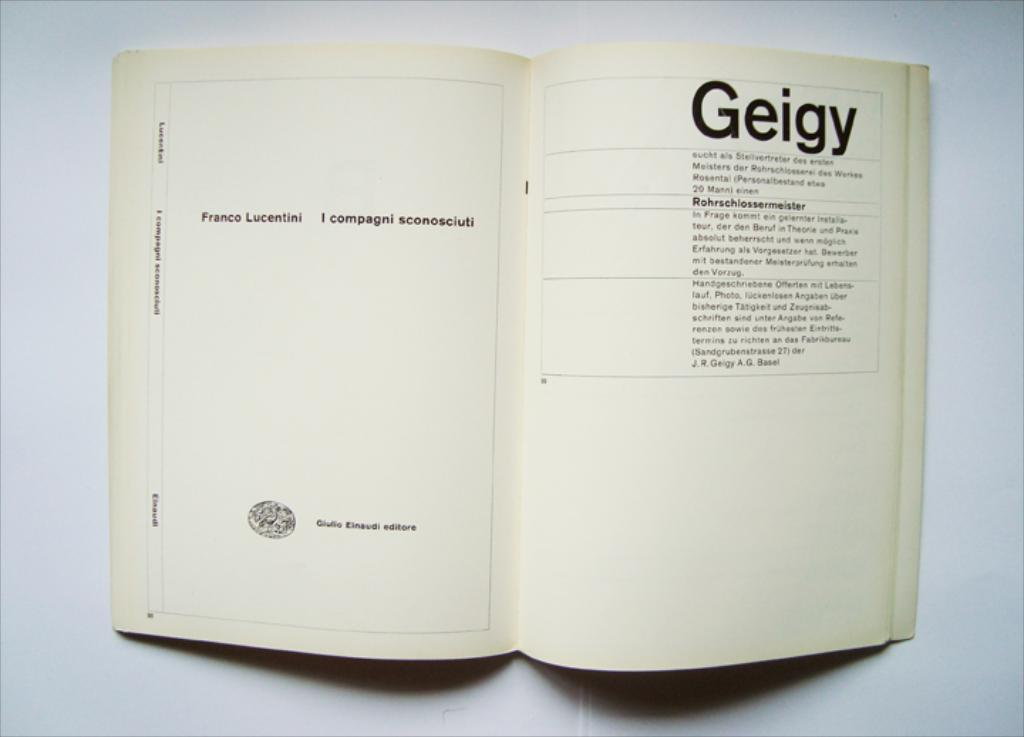What object can be seen in the image? There is a book in the image. What is the state of the book? The book is open. What can be found on the papers in the book? There is text on the papers. What color is the background in the image? The background is white. What type of breakfast is being served on the ground in the image? There is no breakfast or ground present in the image; it only features a book with text on the papers and a white background. 